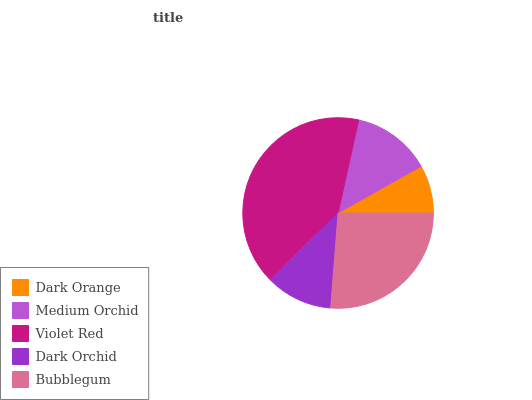Is Dark Orange the minimum?
Answer yes or no. Yes. Is Violet Red the maximum?
Answer yes or no. Yes. Is Medium Orchid the minimum?
Answer yes or no. No. Is Medium Orchid the maximum?
Answer yes or no. No. Is Medium Orchid greater than Dark Orange?
Answer yes or no. Yes. Is Dark Orange less than Medium Orchid?
Answer yes or no. Yes. Is Dark Orange greater than Medium Orchid?
Answer yes or no. No. Is Medium Orchid less than Dark Orange?
Answer yes or no. No. Is Medium Orchid the high median?
Answer yes or no. Yes. Is Medium Orchid the low median?
Answer yes or no. Yes. Is Violet Red the high median?
Answer yes or no. No. Is Dark Orchid the low median?
Answer yes or no. No. 